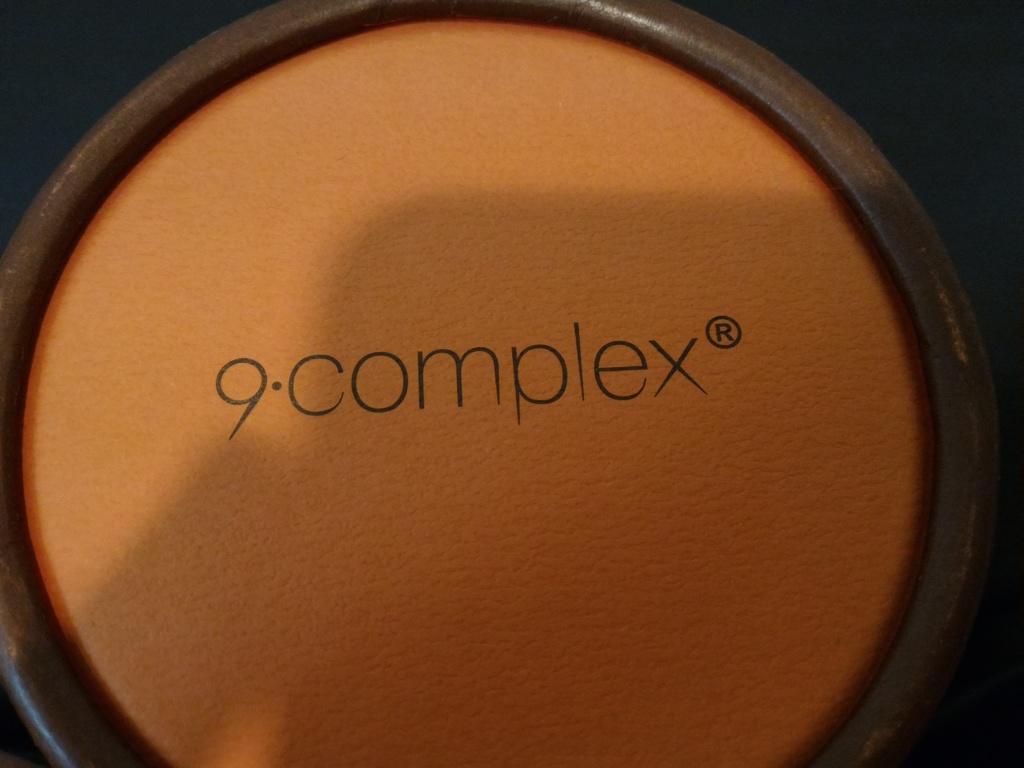In one or two sentences, can you explain what this image depicts? This is a powder in the container. 